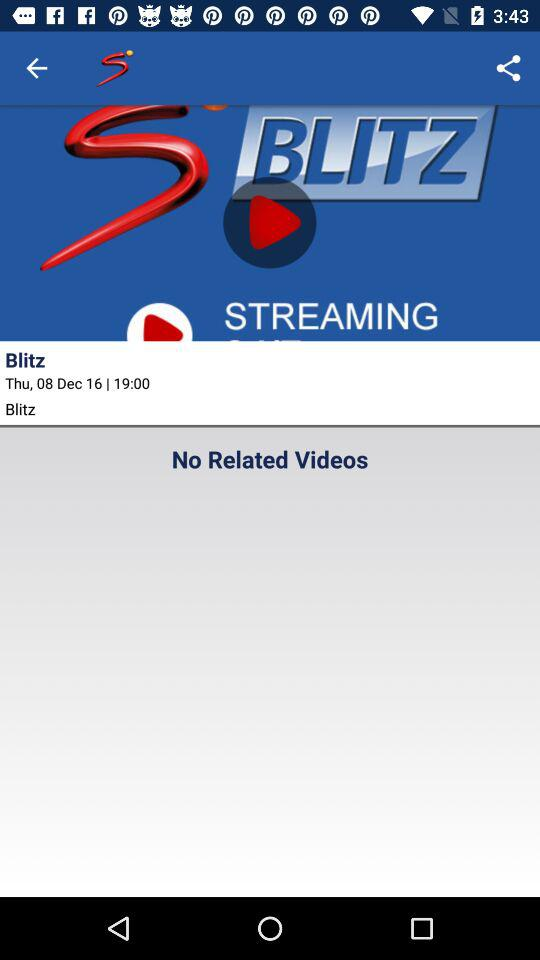What is the date and time of the "Blitz"? The date and time are Thursday, December 8, 2016 and 19:00. 